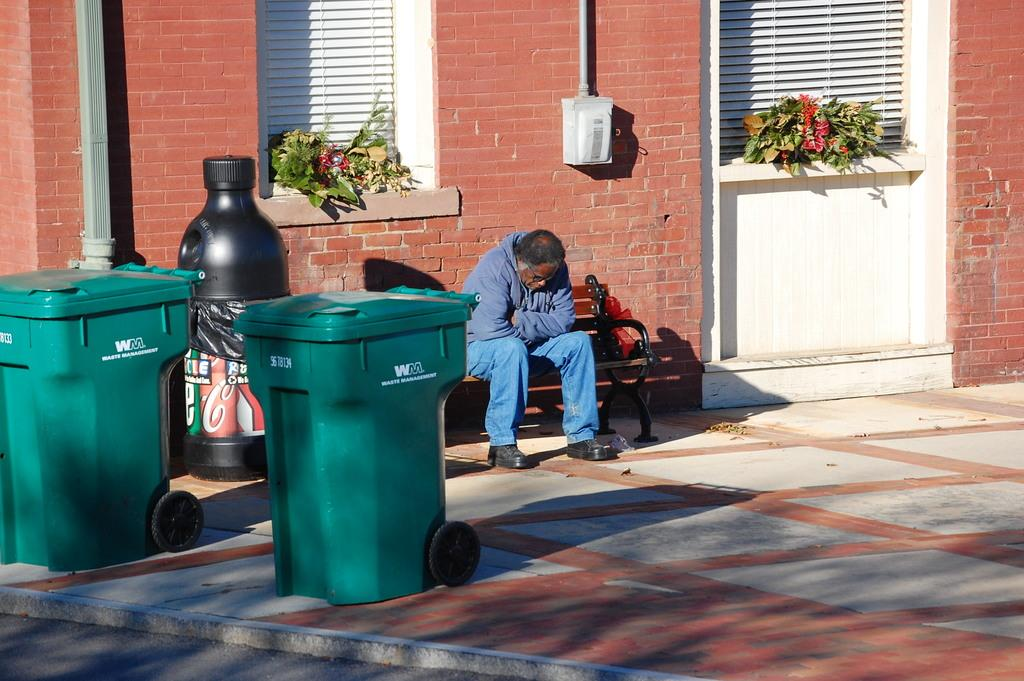<image>
Create a compact narrative representing the image presented. The trash cans that are in front of the man on the bench are from WM Waste Management. 